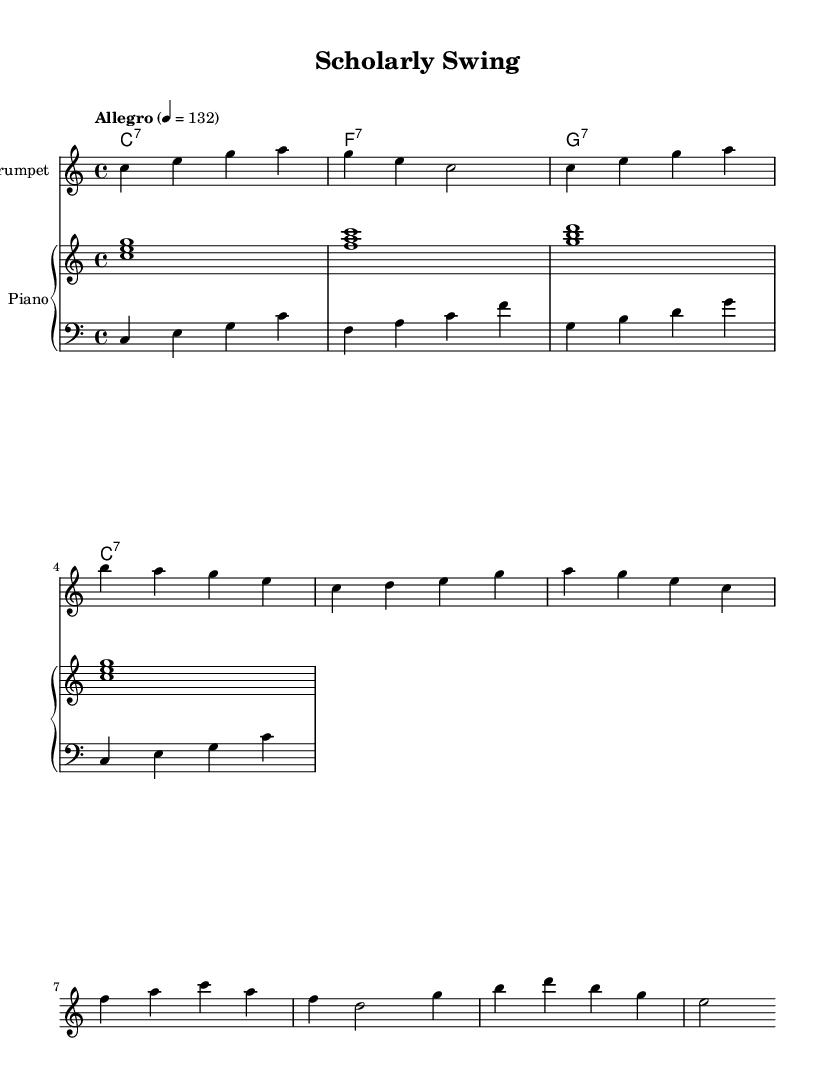What is the key signature of this music? The key signature is C major, which has no sharps or flats.
Answer: C major What is the time signature of this music? The time signature is indicated as 4/4, meaning there are four beats in a measure.
Answer: 4/4 What is the tempo marking for this piece? The tempo marking specifies "Allegro," indicating a lively and fast pace, particularly set at a metronome marking of 132 beats per minute.
Answer: Allegro How many measures are in the intro section? The intro consists of one measure, as indicated by the notation.
Answer: 1 What is the name of the primary instrument in this score? The primary instrument is specified as the trumpet.
Answer: Trumpet What type of chord is played on the first measure of the piano? The first chord played in the right hand of the piano is a C major chord, consisting of the notes C, E, and G.
Answer: C major How many different chord types are presented in the chord changes section? The chord changes section presents three different chord types: C7, F7, and G7, which are common in blues music.
Answer: 3 